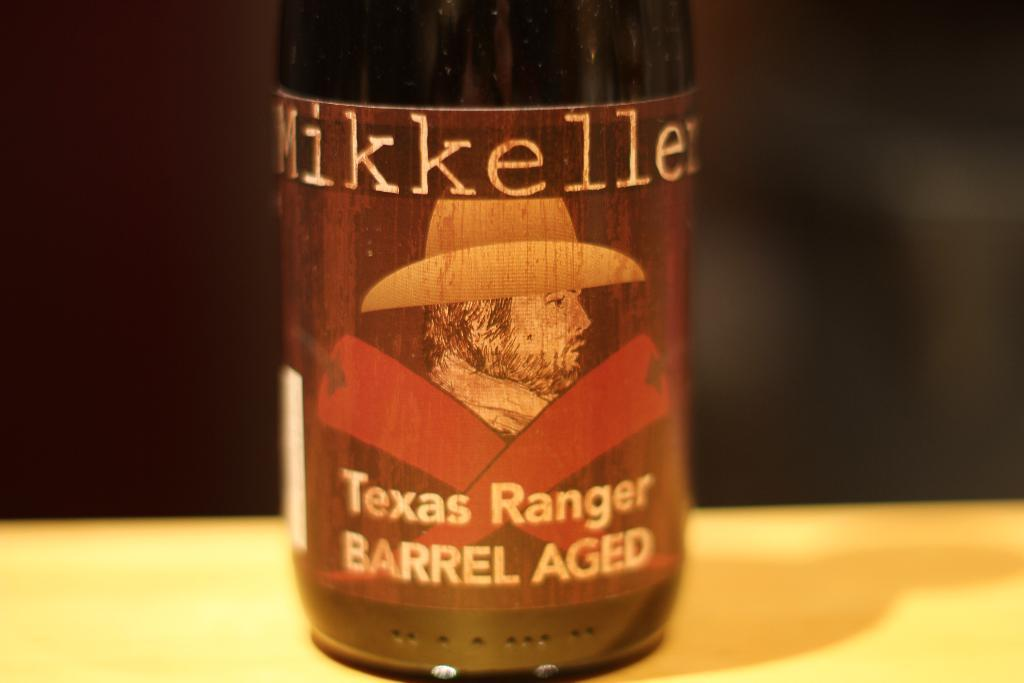<image>
Write a terse but informative summary of the picture. A bottle with a sketch of a cowboy on it is labeled Mikkelle, Texas Ranger Barrel Aged. 